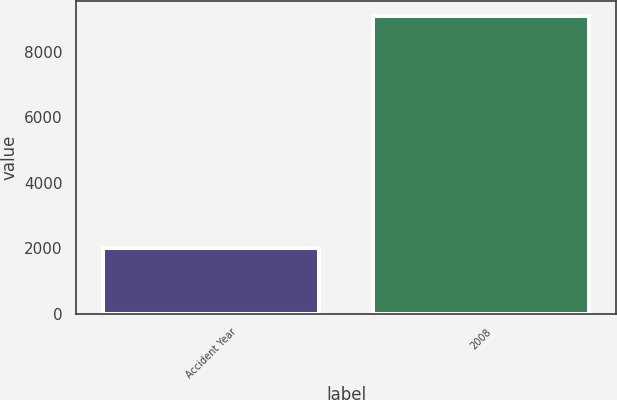<chart> <loc_0><loc_0><loc_500><loc_500><bar_chart><fcel>Accident Year<fcel>2008<nl><fcel>2011<fcel>9111<nl></chart> 